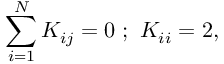Convert formula to latex. <formula><loc_0><loc_0><loc_500><loc_500>\sum _ { i = 1 } ^ { N } K _ { i j } = 0 \ ; \ K _ { i i } = 2 ,</formula> 